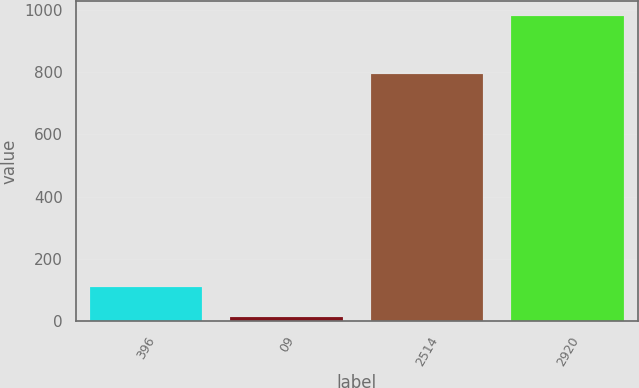Convert chart to OTSL. <chart><loc_0><loc_0><loc_500><loc_500><bar_chart><fcel>396<fcel>09<fcel>2514<fcel>2920<nl><fcel>111.53<fcel>15.1<fcel>792.8<fcel>979.4<nl></chart> 